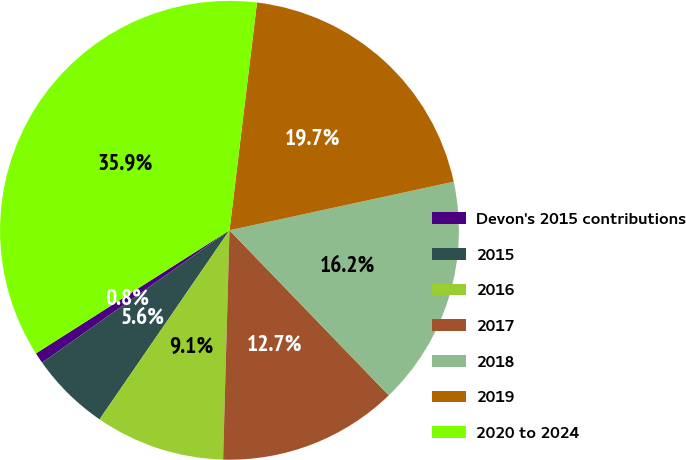Convert chart to OTSL. <chart><loc_0><loc_0><loc_500><loc_500><pie_chart><fcel>Devon's 2015 contributions<fcel>2015<fcel>2016<fcel>2017<fcel>2018<fcel>2019<fcel>2020 to 2024<nl><fcel>0.77%<fcel>5.63%<fcel>9.14%<fcel>12.66%<fcel>16.18%<fcel>19.69%<fcel>35.93%<nl></chart> 